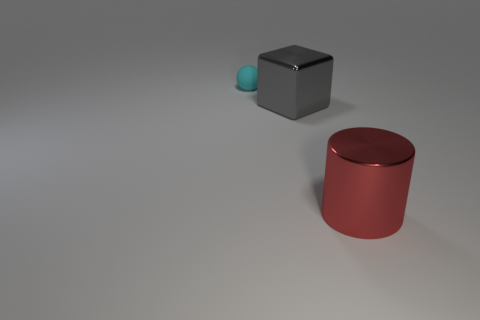What objects are visible in this image? The image features three distinct objects placed on a flat surface: a large red cylinder, a smaller teal sphere, and a medium-sized grey cube. 